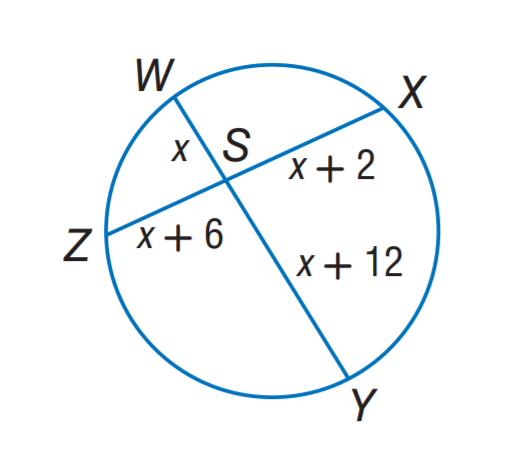Question: Find x.
Choices:
A. 2
B. 3
C. 4
D. 5
Answer with the letter. Answer: B 